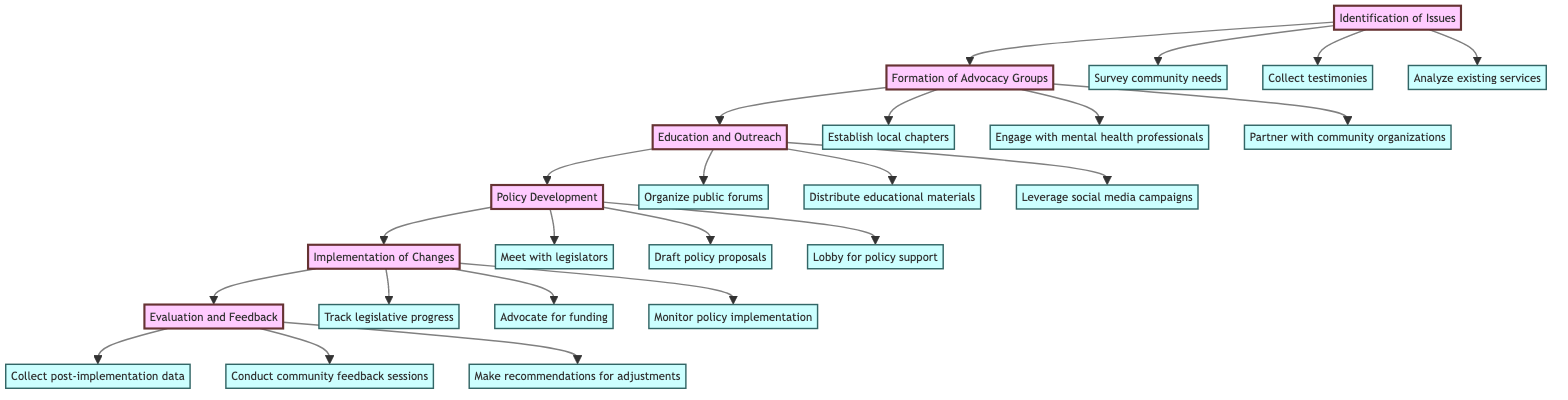What is the first step in the pathway? The first step listed in the clinical pathway is "Identification of Issues," which is at the beginning of the sequence and indicates where the advocacy process starts.
Answer: Identification of Issues How many steps are in the clinical pathway? By examining the diagram, one can count the distinct steps listed, which total six steps from "Identification of Issues" to "Evaluation and Feedback."
Answer: 6 What action is associated with the "Education and Outreach" step? The actions connected to "Education and Outreach" are "Organize public forums," "Distribute educational materials," and "Leverage social media campaigns." The first action mentioned is the one that directly corresponds to the step.
Answer: Organize public forums Which step follows the "Policy Development" step? By tracing the flow of the diagram, the step that immediately comes after "Policy Development" is "Implementation of Changes," indicating the sequence of events in the advocacy process.
Answer: Implementation of Changes What is the last action listed under the "Evaluation and Feedback" step? The final action associated with "Evaluation and Feedback" is "Make recommendations for adjustments," which is the concluding activity in assessing the impact of reforms.
Answer: Make recommendations for adjustments Which two steps are linked directly without any actions in between? The two steps that connect directly without any actions separating them are "Formation of Advocacy Groups" and "Education and Outreach," creating a clear progression from forming groups to educating the community.
Answer: Formation of Advocacy Groups, Education and Outreach What type of organizations might grassroots activists partner with according to the pathway? The pathway mentions "community organizations" specifically as the type of organizations that grassroots activists are encouraged to partner with, fostering collaborative efforts.
Answer: Community organizations How do grassroots activists collect community feedback after changes are implemented? The pathway specifies that community feedback is collected through "Conduct community feedback sessions," which is a direct action for gathering opinions post-implementation.
Answer: Conduct community feedback sessions What is the main focus of the "Implementation of Changes" step? The main focus of this step includes actions like "Track legislative progress," "Advocate for funding," and "Monitor policy implementation," which collectively aim to ensure that reforms are enacted effectively.
Answer: Ensure the enactment and monitoring of policies 